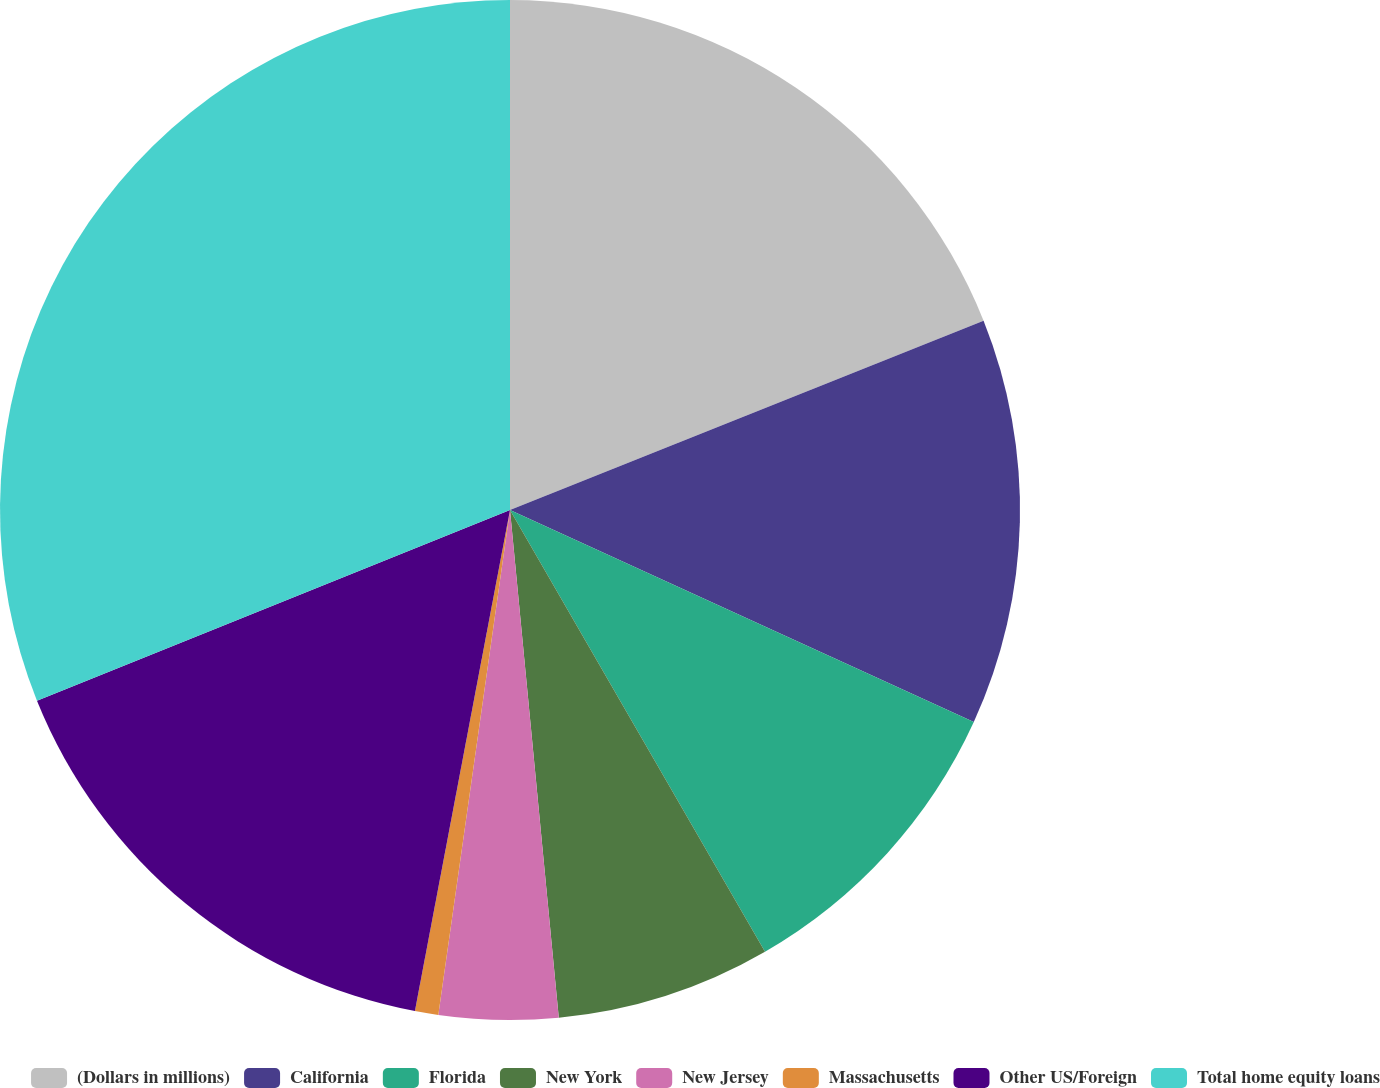<chart> <loc_0><loc_0><loc_500><loc_500><pie_chart><fcel>(Dollars in millions)<fcel>California<fcel>Florida<fcel>New York<fcel>New Jersey<fcel>Massachusetts<fcel>Other US/Foreign<fcel>Total home equity loans<nl><fcel>18.95%<fcel>12.88%<fcel>9.84%<fcel>6.81%<fcel>3.77%<fcel>0.74%<fcel>15.92%<fcel>31.1%<nl></chart> 